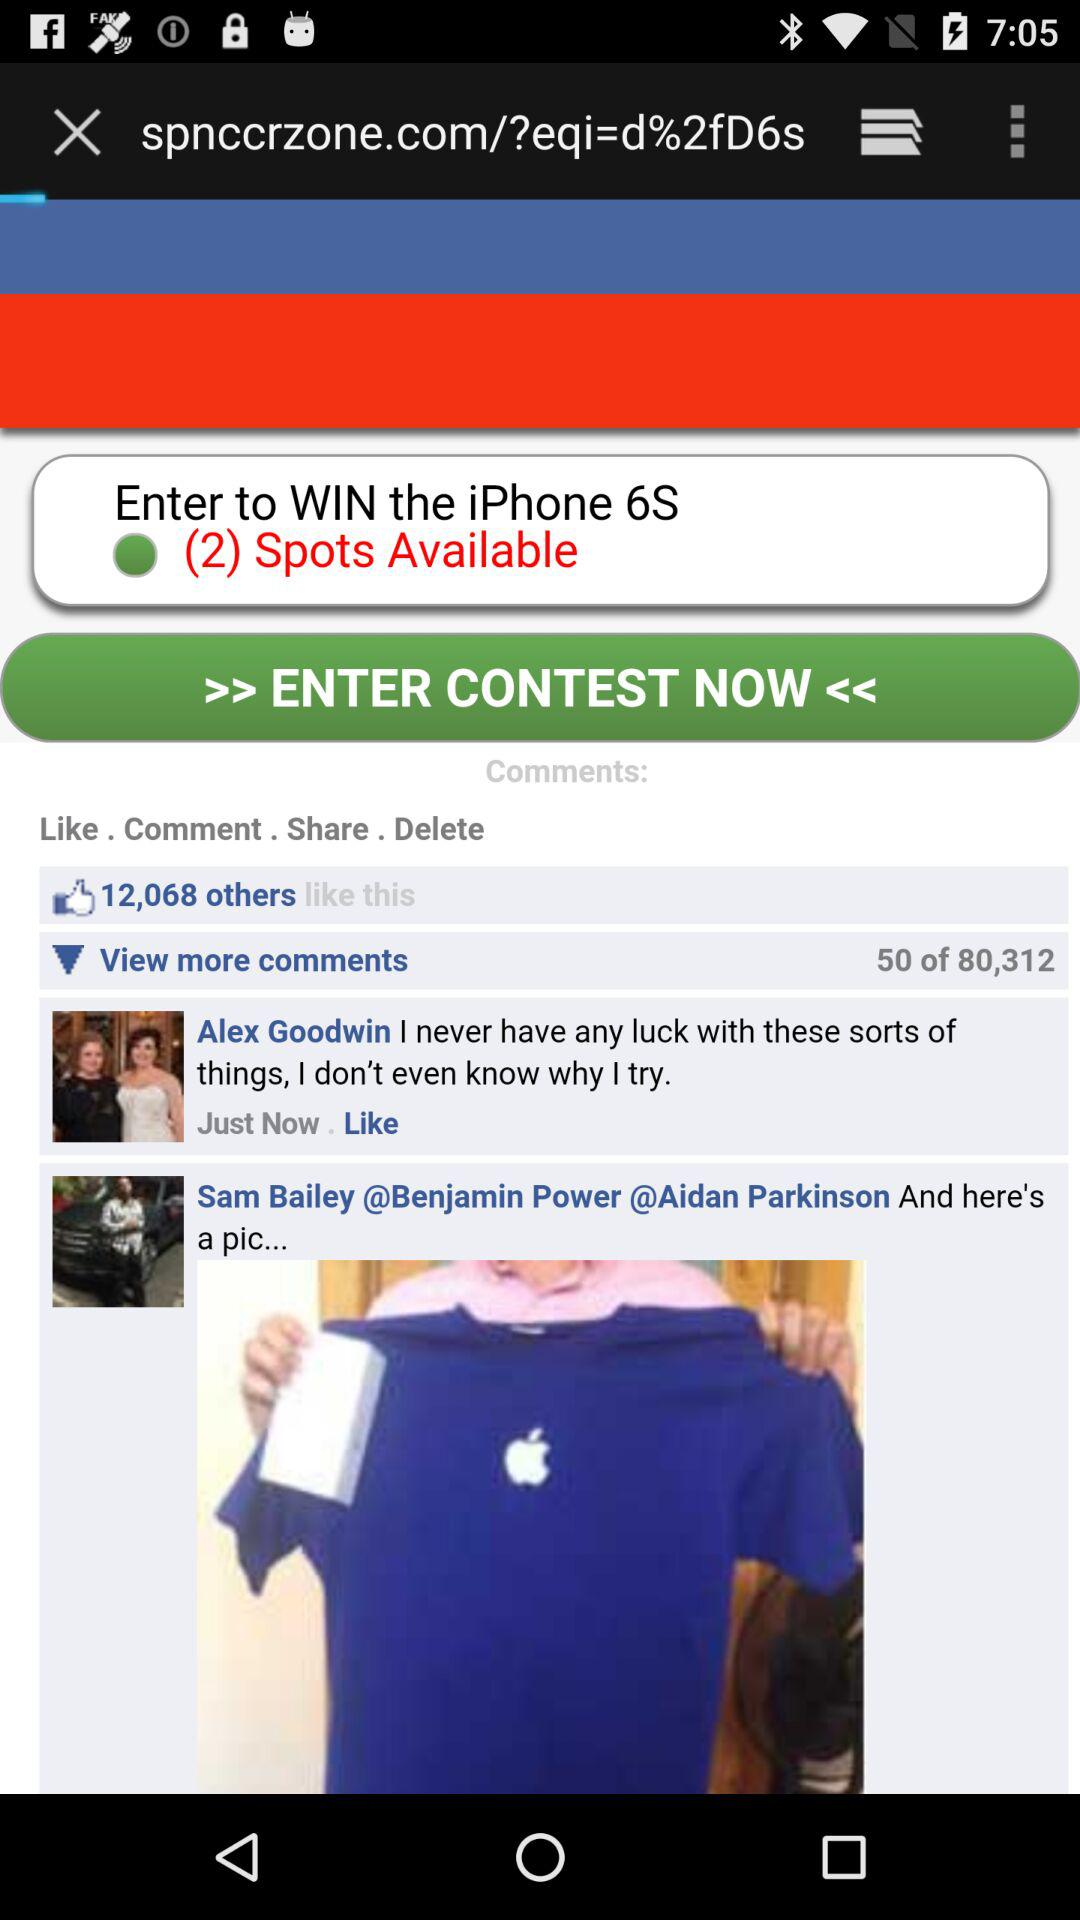How many comments are there? There are 80,312 comments. 